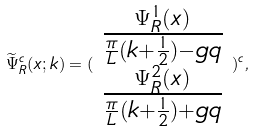<formula> <loc_0><loc_0><loc_500><loc_500>\widetilde { \Psi } _ { R } ^ { c } ( x ; k ) = ( \begin{array} { c } \frac { \Psi _ { R } ^ { 1 } ( x ) } { \frac { \pi } { L } ( k + \frac { 1 } { 2 } ) - g q } \\ \frac { \Psi _ { R } ^ { 2 } ( x ) } { \frac { \pi } { L } ( k + \frac { 1 } { 2 } ) + g q } \end{array} ) ^ { c } ,</formula> 